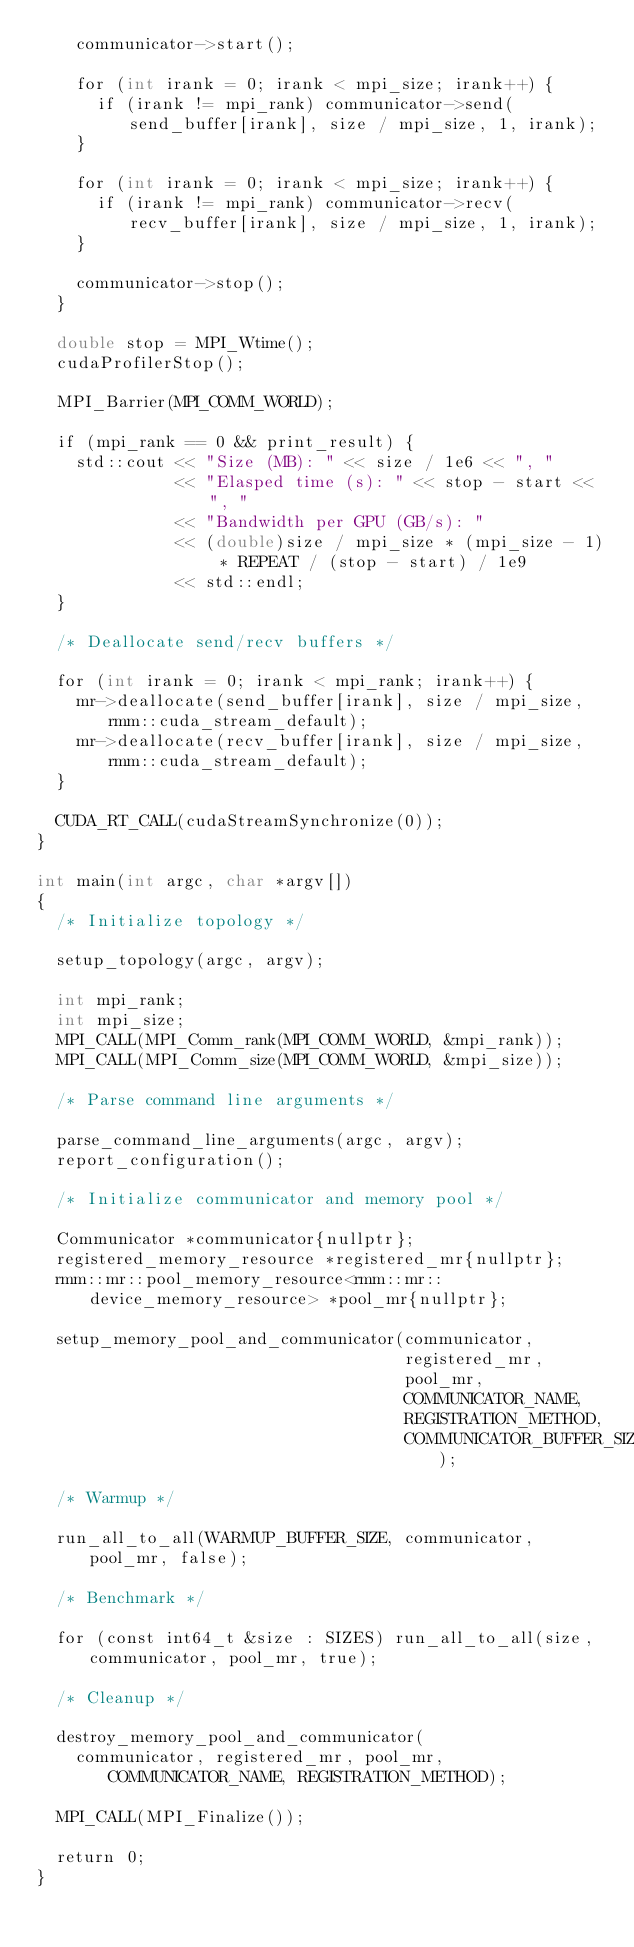<code> <loc_0><loc_0><loc_500><loc_500><_Cuda_>    communicator->start();

    for (int irank = 0; irank < mpi_size; irank++) {
      if (irank != mpi_rank) communicator->send(send_buffer[irank], size / mpi_size, 1, irank);
    }

    for (int irank = 0; irank < mpi_size; irank++) {
      if (irank != mpi_rank) communicator->recv(recv_buffer[irank], size / mpi_size, 1, irank);
    }

    communicator->stop();
  }

  double stop = MPI_Wtime();
  cudaProfilerStop();

  MPI_Barrier(MPI_COMM_WORLD);

  if (mpi_rank == 0 && print_result) {
    std::cout << "Size (MB): " << size / 1e6 << ", "
              << "Elasped time (s): " << stop - start << ", "
              << "Bandwidth per GPU (GB/s): "
              << (double)size / mpi_size * (mpi_size - 1) * REPEAT / (stop - start) / 1e9
              << std::endl;
  }

  /* Deallocate send/recv buffers */

  for (int irank = 0; irank < mpi_rank; irank++) {
    mr->deallocate(send_buffer[irank], size / mpi_size, rmm::cuda_stream_default);
    mr->deallocate(recv_buffer[irank], size / mpi_size, rmm::cuda_stream_default);
  }

  CUDA_RT_CALL(cudaStreamSynchronize(0));
}

int main(int argc, char *argv[])
{
  /* Initialize topology */

  setup_topology(argc, argv);

  int mpi_rank;
  int mpi_size;
  MPI_CALL(MPI_Comm_rank(MPI_COMM_WORLD, &mpi_rank));
  MPI_CALL(MPI_Comm_size(MPI_COMM_WORLD, &mpi_size));

  /* Parse command line arguments */

  parse_command_line_arguments(argc, argv);
  report_configuration();

  /* Initialize communicator and memory pool */

  Communicator *communicator{nullptr};
  registered_memory_resource *registered_mr{nullptr};
  rmm::mr::pool_memory_resource<rmm::mr::device_memory_resource> *pool_mr{nullptr};

  setup_memory_pool_and_communicator(communicator,
                                     registered_mr,
                                     pool_mr,
                                     COMMUNICATOR_NAME,
                                     REGISTRATION_METHOD,
                                     COMMUNICATOR_BUFFER_SIZE);

  /* Warmup */

  run_all_to_all(WARMUP_BUFFER_SIZE, communicator, pool_mr, false);

  /* Benchmark */

  for (const int64_t &size : SIZES) run_all_to_all(size, communicator, pool_mr, true);

  /* Cleanup */

  destroy_memory_pool_and_communicator(
    communicator, registered_mr, pool_mr, COMMUNICATOR_NAME, REGISTRATION_METHOD);

  MPI_CALL(MPI_Finalize());

  return 0;
}
</code> 